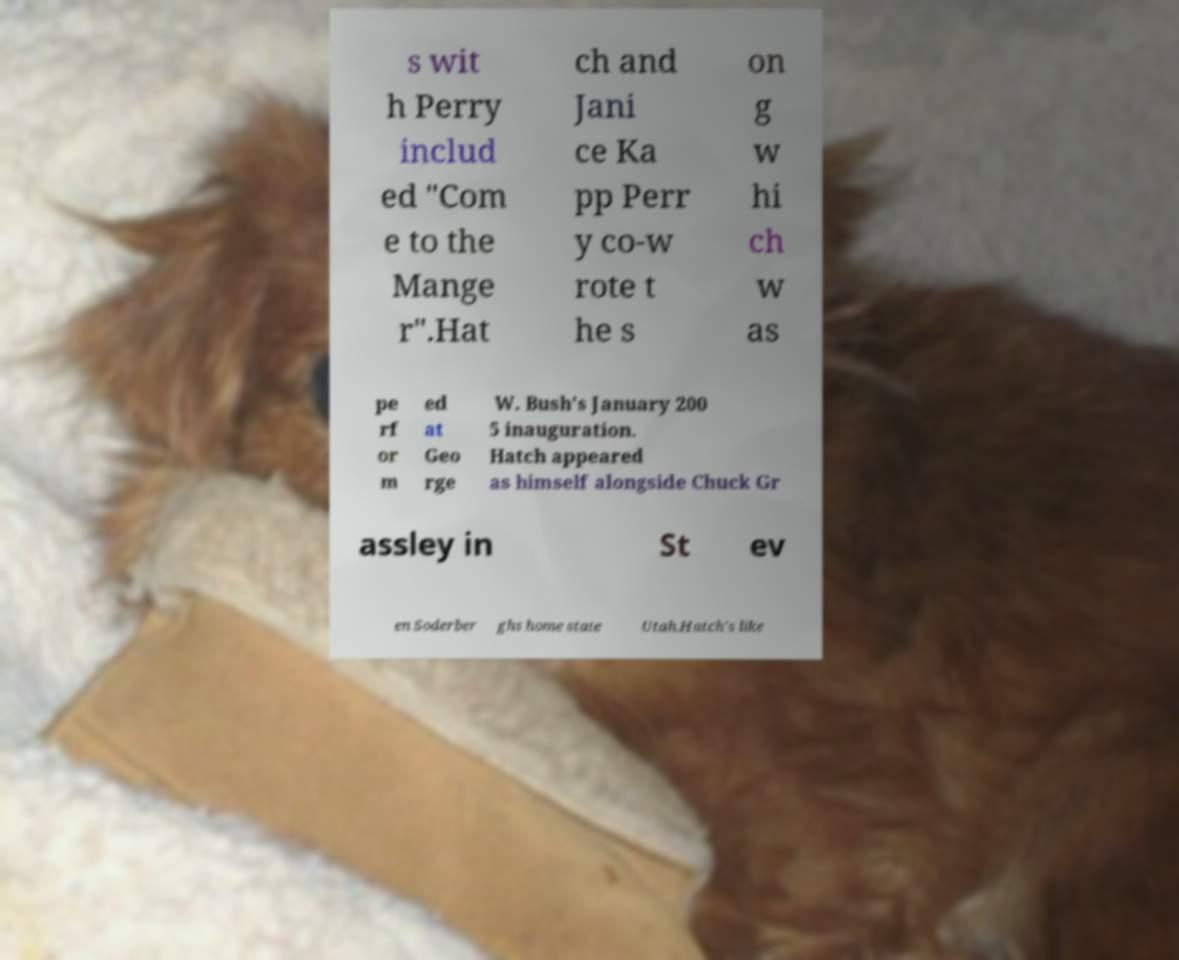There's text embedded in this image that I need extracted. Can you transcribe it verbatim? s wit h Perry includ ed "Com e to the Mange r".Hat ch and Jani ce Ka pp Perr y co-w rote t he s on g w hi ch w as pe rf or m ed at Geo rge W. Bush's January 200 5 inauguration. Hatch appeared as himself alongside Chuck Gr assley in St ev en Soderber ghs home state Utah.Hatch's like 